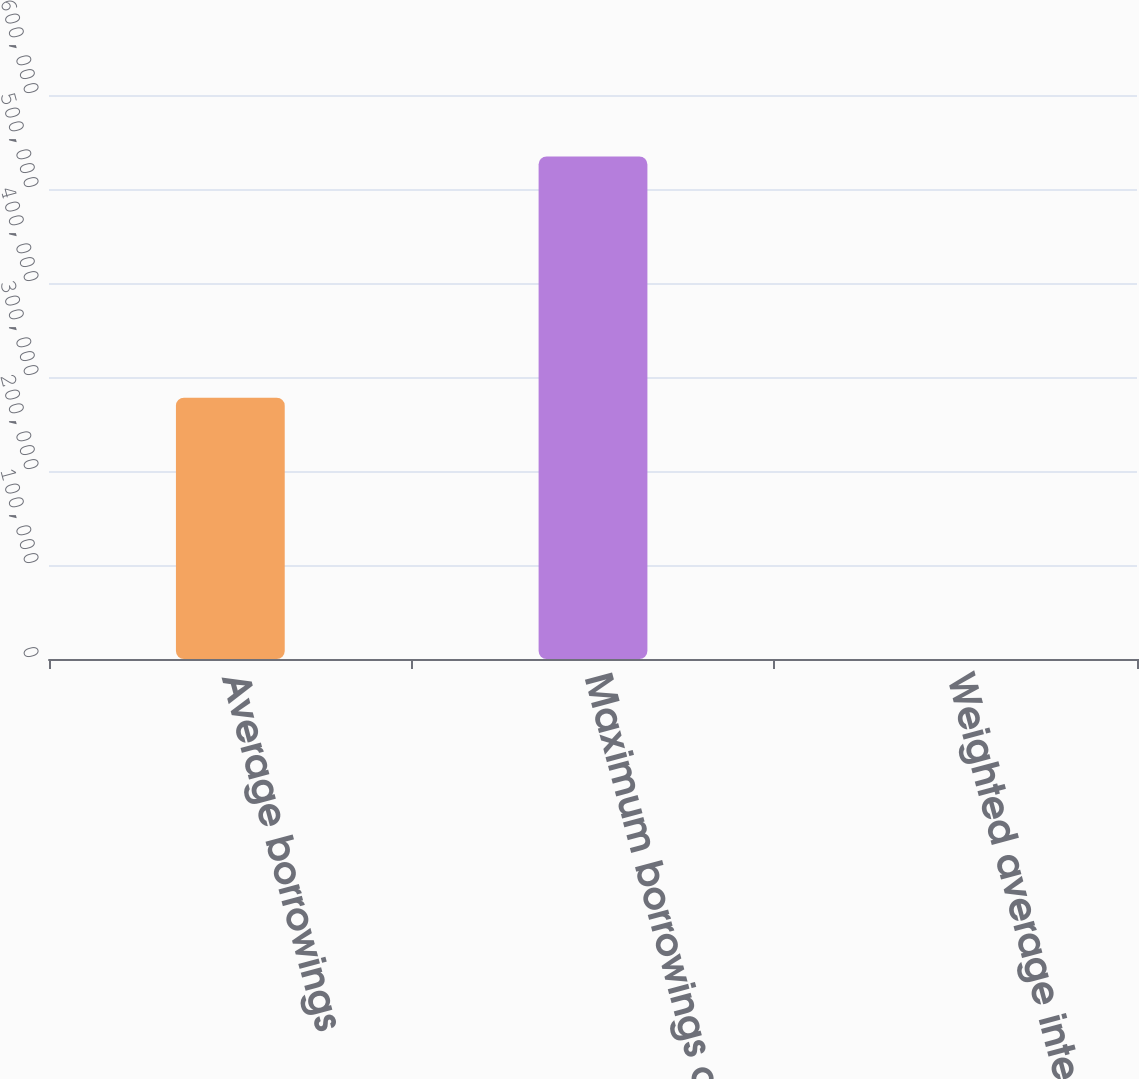Convert chart to OTSL. <chart><loc_0><loc_0><loc_500><loc_500><bar_chart><fcel>Average borrowings<fcel>Maximum borrowings outstanding<fcel>Weighted average interest<nl><fcel>277952<fcel>534700<fcel>0.46<nl></chart> 